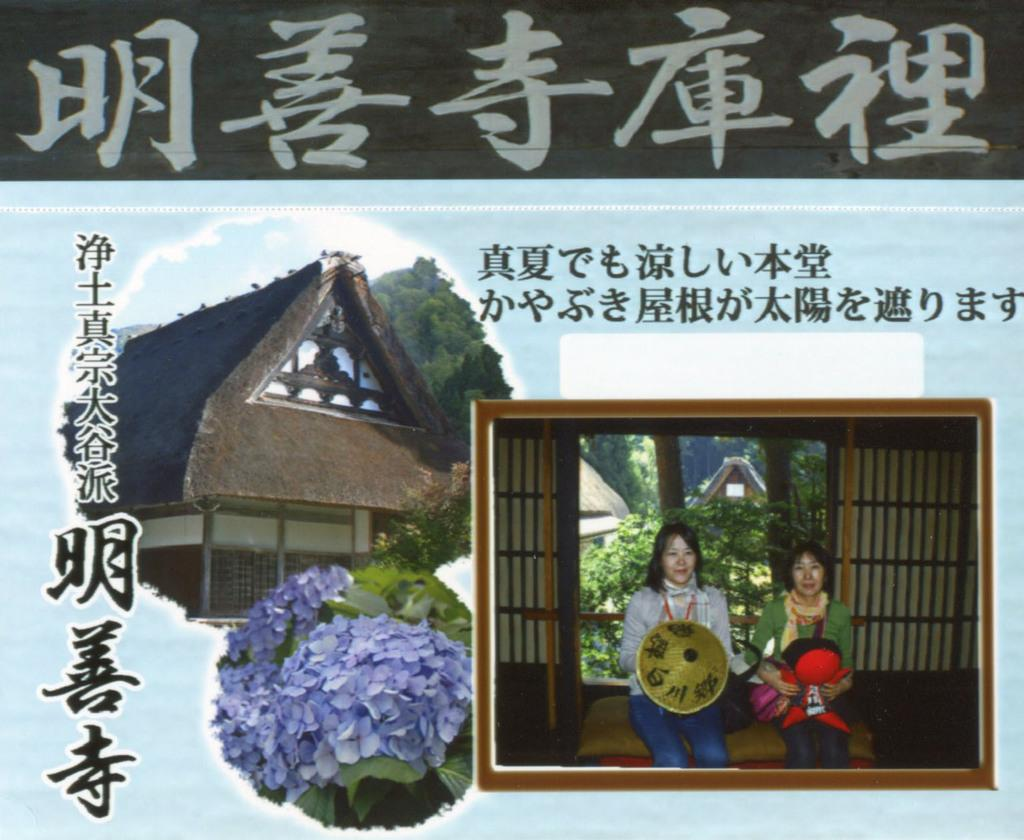What is featured on the poster in the image? The poster contains two women sitting. What are the women doing in the poster? The women are holding objects in the poster. What type of structure is visible in the image? A: There is a house visible in the image. What type of vegetation can be seen in the image? There are trees and plants in the image. Is there a queen in the image, and if so, where is she located? There is no queen present in the image. Can you see a carpenter working on a project in the image? There is no carpenter or any indication of woodworking in the image. 